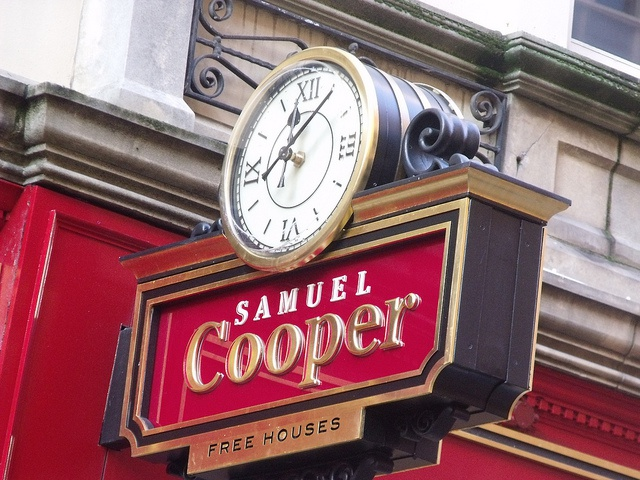Describe the objects in this image and their specific colors. I can see a clock in white, darkgray, gray, and tan tones in this image. 